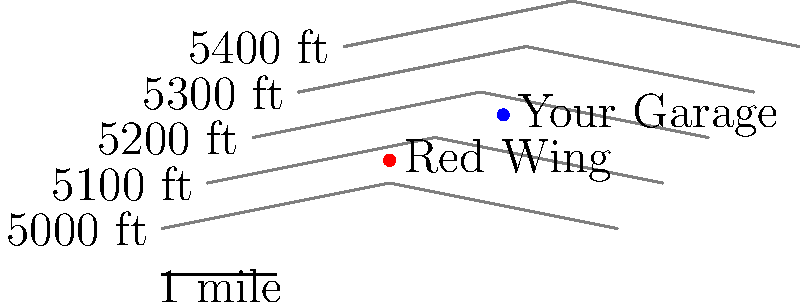Based on the topographic map of Red Wing, Colorado and its surroundings, what is the approximate elevation of your garage where you plan to build your man cave? To determine the approximate elevation of the garage:

1. Locate the garage on the map (blue dot labeled "Your Garage").
2. Identify the contour lines above and below the garage location.
3. The garage is between the 5200 ft and 5300 ft contour lines.
4. Estimate the position of the garage between these lines:
   - It appears to be slightly closer to the 5300 ft line.
   - We can estimate it's about 2/3 of the way from 5200 ft to 5300 ft.
5. Calculate the approximate elevation:
   $5200 + (\frac{2}{3} \times (5300 - 5200)) = 5200 + (\frac{2}{3} \times 100) = 5200 + 66.67$

Therefore, the approximate elevation of the garage is about 5267 feet.
Answer: Approximately 5270 feet 